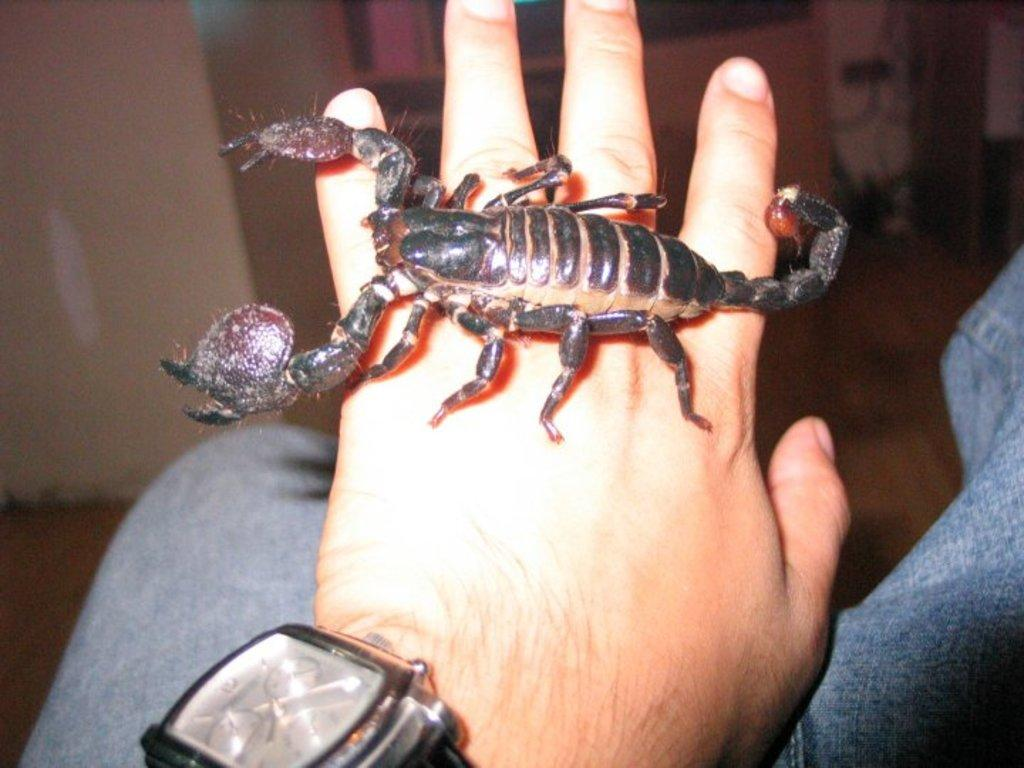What is the main subject of the picture? The main subject of the picture is a black color scorpion. Where is the scorpion located in the image? The scorpion is on a human hand. Can you describe any additional details about the person holding the scorpion? The person wearing the scorpion is wearing a wrist watch. In which direction is the scorpion facing in the image? The provided facts do not mention the direction the scorpion is facing, so it cannot be determined from the image. What is the size of the spy in the image? There is no mention of a spy in the image, so it cannot be determined from the image. 